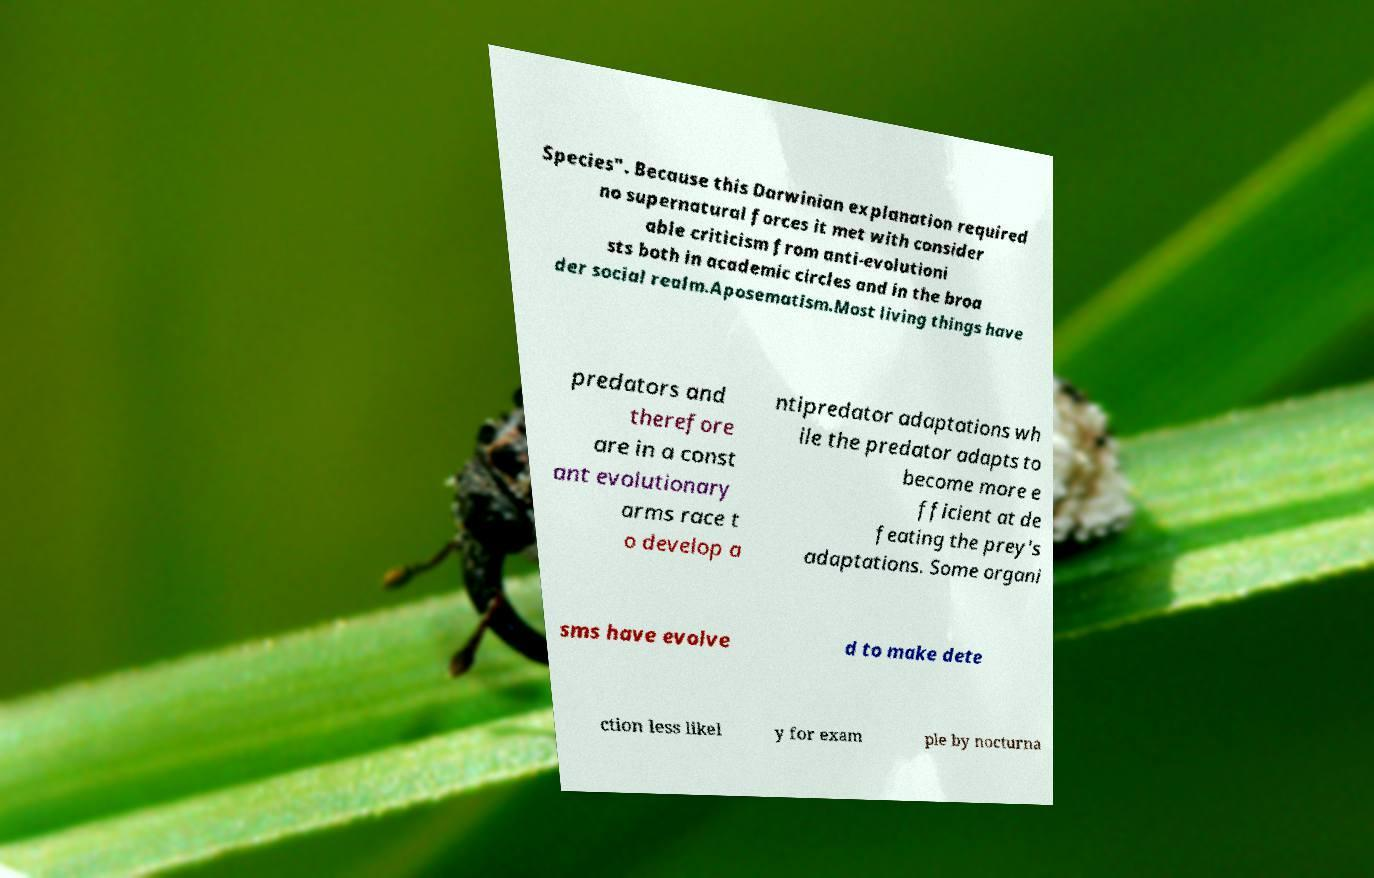Could you assist in decoding the text presented in this image and type it out clearly? Species". Because this Darwinian explanation required no supernatural forces it met with consider able criticism from anti-evolutioni sts both in academic circles and in the broa der social realm.Aposematism.Most living things have predators and therefore are in a const ant evolutionary arms race t o develop a ntipredator adaptations wh ile the predator adapts to become more e fficient at de feating the prey's adaptations. Some organi sms have evolve d to make dete ction less likel y for exam ple by nocturna 